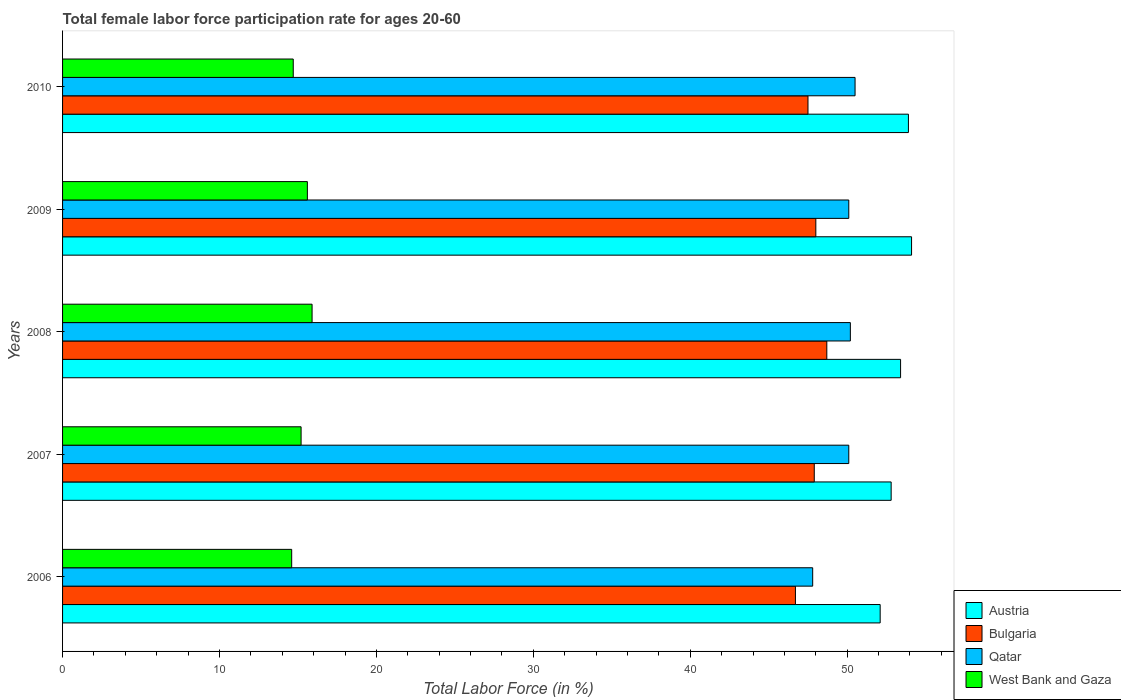How many different coloured bars are there?
Provide a succinct answer. 4. How many bars are there on the 4th tick from the top?
Ensure brevity in your answer.  4. What is the label of the 1st group of bars from the top?
Make the answer very short. 2010. What is the female labor force participation rate in West Bank and Gaza in 2007?
Provide a short and direct response. 15.2. Across all years, what is the maximum female labor force participation rate in West Bank and Gaza?
Your answer should be compact. 15.9. Across all years, what is the minimum female labor force participation rate in Bulgaria?
Provide a short and direct response. 46.7. In which year was the female labor force participation rate in Qatar minimum?
Provide a short and direct response. 2006. What is the total female labor force participation rate in Bulgaria in the graph?
Offer a very short reply. 238.8. What is the difference between the female labor force participation rate in Austria in 2008 and that in 2009?
Offer a terse response. -0.7. What is the difference between the female labor force participation rate in Bulgaria in 2010 and the female labor force participation rate in Qatar in 2007?
Your answer should be very brief. -2.6. What is the average female labor force participation rate in Bulgaria per year?
Ensure brevity in your answer.  47.76. In the year 2007, what is the difference between the female labor force participation rate in Austria and female labor force participation rate in West Bank and Gaza?
Offer a very short reply. 37.6. What is the ratio of the female labor force participation rate in Qatar in 2006 to that in 2008?
Keep it short and to the point. 0.95. Is the difference between the female labor force participation rate in Austria in 2008 and 2009 greater than the difference between the female labor force participation rate in West Bank and Gaza in 2008 and 2009?
Offer a very short reply. No. What is the difference between the highest and the second highest female labor force participation rate in Austria?
Offer a very short reply. 0.2. What is the difference between the highest and the lowest female labor force participation rate in Bulgaria?
Provide a short and direct response. 2. In how many years, is the female labor force participation rate in West Bank and Gaza greater than the average female labor force participation rate in West Bank and Gaza taken over all years?
Keep it short and to the point. 2. Is it the case that in every year, the sum of the female labor force participation rate in Qatar and female labor force participation rate in West Bank and Gaza is greater than the sum of female labor force participation rate in Austria and female labor force participation rate in Bulgaria?
Make the answer very short. Yes. What does the 1st bar from the top in 2006 represents?
Provide a short and direct response. West Bank and Gaza. What does the 3rd bar from the bottom in 2010 represents?
Keep it short and to the point. Qatar. How many bars are there?
Your answer should be very brief. 20. Are all the bars in the graph horizontal?
Offer a very short reply. Yes. What is the difference between two consecutive major ticks on the X-axis?
Your response must be concise. 10. Does the graph contain any zero values?
Give a very brief answer. No. Does the graph contain grids?
Keep it short and to the point. No. How are the legend labels stacked?
Keep it short and to the point. Vertical. What is the title of the graph?
Provide a succinct answer. Total female labor force participation rate for ages 20-60. What is the label or title of the X-axis?
Offer a very short reply. Total Labor Force (in %). What is the label or title of the Y-axis?
Offer a terse response. Years. What is the Total Labor Force (in %) of Austria in 2006?
Provide a succinct answer. 52.1. What is the Total Labor Force (in %) in Bulgaria in 2006?
Ensure brevity in your answer.  46.7. What is the Total Labor Force (in %) of Qatar in 2006?
Provide a succinct answer. 47.8. What is the Total Labor Force (in %) in West Bank and Gaza in 2006?
Your answer should be very brief. 14.6. What is the Total Labor Force (in %) in Austria in 2007?
Provide a succinct answer. 52.8. What is the Total Labor Force (in %) in Bulgaria in 2007?
Give a very brief answer. 47.9. What is the Total Labor Force (in %) of Qatar in 2007?
Keep it short and to the point. 50.1. What is the Total Labor Force (in %) of West Bank and Gaza in 2007?
Provide a short and direct response. 15.2. What is the Total Labor Force (in %) of Austria in 2008?
Your answer should be compact. 53.4. What is the Total Labor Force (in %) of Bulgaria in 2008?
Offer a terse response. 48.7. What is the Total Labor Force (in %) of Qatar in 2008?
Offer a terse response. 50.2. What is the Total Labor Force (in %) of West Bank and Gaza in 2008?
Provide a short and direct response. 15.9. What is the Total Labor Force (in %) of Austria in 2009?
Ensure brevity in your answer.  54.1. What is the Total Labor Force (in %) of Bulgaria in 2009?
Make the answer very short. 48. What is the Total Labor Force (in %) of Qatar in 2009?
Make the answer very short. 50.1. What is the Total Labor Force (in %) of West Bank and Gaza in 2009?
Provide a short and direct response. 15.6. What is the Total Labor Force (in %) of Austria in 2010?
Make the answer very short. 53.9. What is the Total Labor Force (in %) in Bulgaria in 2010?
Make the answer very short. 47.5. What is the Total Labor Force (in %) in Qatar in 2010?
Your response must be concise. 50.5. What is the Total Labor Force (in %) in West Bank and Gaza in 2010?
Provide a short and direct response. 14.7. Across all years, what is the maximum Total Labor Force (in %) in Austria?
Keep it short and to the point. 54.1. Across all years, what is the maximum Total Labor Force (in %) in Bulgaria?
Keep it short and to the point. 48.7. Across all years, what is the maximum Total Labor Force (in %) in Qatar?
Offer a terse response. 50.5. Across all years, what is the maximum Total Labor Force (in %) in West Bank and Gaza?
Offer a very short reply. 15.9. Across all years, what is the minimum Total Labor Force (in %) of Austria?
Make the answer very short. 52.1. Across all years, what is the minimum Total Labor Force (in %) in Bulgaria?
Provide a succinct answer. 46.7. Across all years, what is the minimum Total Labor Force (in %) in Qatar?
Your answer should be very brief. 47.8. Across all years, what is the minimum Total Labor Force (in %) of West Bank and Gaza?
Provide a succinct answer. 14.6. What is the total Total Labor Force (in %) in Austria in the graph?
Give a very brief answer. 266.3. What is the total Total Labor Force (in %) of Bulgaria in the graph?
Your response must be concise. 238.8. What is the total Total Labor Force (in %) in Qatar in the graph?
Ensure brevity in your answer.  248.7. What is the total Total Labor Force (in %) in West Bank and Gaza in the graph?
Your response must be concise. 76. What is the difference between the Total Labor Force (in %) of Qatar in 2006 and that in 2007?
Offer a terse response. -2.3. What is the difference between the Total Labor Force (in %) of Austria in 2006 and that in 2008?
Provide a succinct answer. -1.3. What is the difference between the Total Labor Force (in %) in Bulgaria in 2006 and that in 2008?
Give a very brief answer. -2. What is the difference between the Total Labor Force (in %) in West Bank and Gaza in 2006 and that in 2009?
Give a very brief answer. -1. What is the difference between the Total Labor Force (in %) of Austria in 2006 and that in 2010?
Offer a very short reply. -1.8. What is the difference between the Total Labor Force (in %) of Bulgaria in 2006 and that in 2010?
Your answer should be compact. -0.8. What is the difference between the Total Labor Force (in %) in Qatar in 2006 and that in 2010?
Make the answer very short. -2.7. What is the difference between the Total Labor Force (in %) in West Bank and Gaza in 2006 and that in 2010?
Your response must be concise. -0.1. What is the difference between the Total Labor Force (in %) of Austria in 2007 and that in 2008?
Offer a very short reply. -0.6. What is the difference between the Total Labor Force (in %) of Bulgaria in 2007 and that in 2008?
Offer a very short reply. -0.8. What is the difference between the Total Labor Force (in %) in Bulgaria in 2007 and that in 2010?
Offer a very short reply. 0.4. What is the difference between the Total Labor Force (in %) of Bulgaria in 2008 and that in 2009?
Provide a short and direct response. 0.7. What is the difference between the Total Labor Force (in %) in West Bank and Gaza in 2008 and that in 2009?
Your answer should be very brief. 0.3. What is the difference between the Total Labor Force (in %) of Austria in 2008 and that in 2010?
Your response must be concise. -0.5. What is the difference between the Total Labor Force (in %) in Qatar in 2008 and that in 2010?
Your answer should be very brief. -0.3. What is the difference between the Total Labor Force (in %) of West Bank and Gaza in 2008 and that in 2010?
Your answer should be compact. 1.2. What is the difference between the Total Labor Force (in %) of Bulgaria in 2009 and that in 2010?
Keep it short and to the point. 0.5. What is the difference between the Total Labor Force (in %) in Austria in 2006 and the Total Labor Force (in %) in Bulgaria in 2007?
Your response must be concise. 4.2. What is the difference between the Total Labor Force (in %) of Austria in 2006 and the Total Labor Force (in %) of Qatar in 2007?
Give a very brief answer. 2. What is the difference between the Total Labor Force (in %) of Austria in 2006 and the Total Labor Force (in %) of West Bank and Gaza in 2007?
Offer a very short reply. 36.9. What is the difference between the Total Labor Force (in %) in Bulgaria in 2006 and the Total Labor Force (in %) in Qatar in 2007?
Your answer should be compact. -3.4. What is the difference between the Total Labor Force (in %) of Bulgaria in 2006 and the Total Labor Force (in %) of West Bank and Gaza in 2007?
Offer a very short reply. 31.5. What is the difference between the Total Labor Force (in %) of Qatar in 2006 and the Total Labor Force (in %) of West Bank and Gaza in 2007?
Offer a terse response. 32.6. What is the difference between the Total Labor Force (in %) in Austria in 2006 and the Total Labor Force (in %) in Bulgaria in 2008?
Provide a succinct answer. 3.4. What is the difference between the Total Labor Force (in %) in Austria in 2006 and the Total Labor Force (in %) in West Bank and Gaza in 2008?
Ensure brevity in your answer.  36.2. What is the difference between the Total Labor Force (in %) in Bulgaria in 2006 and the Total Labor Force (in %) in Qatar in 2008?
Provide a succinct answer. -3.5. What is the difference between the Total Labor Force (in %) in Bulgaria in 2006 and the Total Labor Force (in %) in West Bank and Gaza in 2008?
Your response must be concise. 30.8. What is the difference between the Total Labor Force (in %) in Qatar in 2006 and the Total Labor Force (in %) in West Bank and Gaza in 2008?
Offer a very short reply. 31.9. What is the difference between the Total Labor Force (in %) of Austria in 2006 and the Total Labor Force (in %) of Qatar in 2009?
Ensure brevity in your answer.  2. What is the difference between the Total Labor Force (in %) of Austria in 2006 and the Total Labor Force (in %) of West Bank and Gaza in 2009?
Provide a succinct answer. 36.5. What is the difference between the Total Labor Force (in %) of Bulgaria in 2006 and the Total Labor Force (in %) of Qatar in 2009?
Your response must be concise. -3.4. What is the difference between the Total Labor Force (in %) in Bulgaria in 2006 and the Total Labor Force (in %) in West Bank and Gaza in 2009?
Offer a terse response. 31.1. What is the difference between the Total Labor Force (in %) of Qatar in 2006 and the Total Labor Force (in %) of West Bank and Gaza in 2009?
Make the answer very short. 32.2. What is the difference between the Total Labor Force (in %) of Austria in 2006 and the Total Labor Force (in %) of Bulgaria in 2010?
Your answer should be very brief. 4.6. What is the difference between the Total Labor Force (in %) in Austria in 2006 and the Total Labor Force (in %) in West Bank and Gaza in 2010?
Your answer should be compact. 37.4. What is the difference between the Total Labor Force (in %) of Qatar in 2006 and the Total Labor Force (in %) of West Bank and Gaza in 2010?
Your answer should be compact. 33.1. What is the difference between the Total Labor Force (in %) in Austria in 2007 and the Total Labor Force (in %) in West Bank and Gaza in 2008?
Provide a succinct answer. 36.9. What is the difference between the Total Labor Force (in %) in Bulgaria in 2007 and the Total Labor Force (in %) in West Bank and Gaza in 2008?
Make the answer very short. 32. What is the difference between the Total Labor Force (in %) of Qatar in 2007 and the Total Labor Force (in %) of West Bank and Gaza in 2008?
Keep it short and to the point. 34.2. What is the difference between the Total Labor Force (in %) in Austria in 2007 and the Total Labor Force (in %) in Qatar in 2009?
Keep it short and to the point. 2.7. What is the difference between the Total Labor Force (in %) of Austria in 2007 and the Total Labor Force (in %) of West Bank and Gaza in 2009?
Your response must be concise. 37.2. What is the difference between the Total Labor Force (in %) of Bulgaria in 2007 and the Total Labor Force (in %) of West Bank and Gaza in 2009?
Ensure brevity in your answer.  32.3. What is the difference between the Total Labor Force (in %) in Qatar in 2007 and the Total Labor Force (in %) in West Bank and Gaza in 2009?
Keep it short and to the point. 34.5. What is the difference between the Total Labor Force (in %) in Austria in 2007 and the Total Labor Force (in %) in Bulgaria in 2010?
Make the answer very short. 5.3. What is the difference between the Total Labor Force (in %) of Austria in 2007 and the Total Labor Force (in %) of Qatar in 2010?
Keep it short and to the point. 2.3. What is the difference between the Total Labor Force (in %) of Austria in 2007 and the Total Labor Force (in %) of West Bank and Gaza in 2010?
Provide a succinct answer. 38.1. What is the difference between the Total Labor Force (in %) in Bulgaria in 2007 and the Total Labor Force (in %) in West Bank and Gaza in 2010?
Your answer should be compact. 33.2. What is the difference between the Total Labor Force (in %) of Qatar in 2007 and the Total Labor Force (in %) of West Bank and Gaza in 2010?
Your response must be concise. 35.4. What is the difference between the Total Labor Force (in %) in Austria in 2008 and the Total Labor Force (in %) in Bulgaria in 2009?
Your answer should be compact. 5.4. What is the difference between the Total Labor Force (in %) in Austria in 2008 and the Total Labor Force (in %) in West Bank and Gaza in 2009?
Your response must be concise. 37.8. What is the difference between the Total Labor Force (in %) of Bulgaria in 2008 and the Total Labor Force (in %) of West Bank and Gaza in 2009?
Your answer should be very brief. 33.1. What is the difference between the Total Labor Force (in %) of Qatar in 2008 and the Total Labor Force (in %) of West Bank and Gaza in 2009?
Your answer should be compact. 34.6. What is the difference between the Total Labor Force (in %) of Austria in 2008 and the Total Labor Force (in %) of West Bank and Gaza in 2010?
Keep it short and to the point. 38.7. What is the difference between the Total Labor Force (in %) of Bulgaria in 2008 and the Total Labor Force (in %) of Qatar in 2010?
Your answer should be very brief. -1.8. What is the difference between the Total Labor Force (in %) of Qatar in 2008 and the Total Labor Force (in %) of West Bank and Gaza in 2010?
Your answer should be compact. 35.5. What is the difference between the Total Labor Force (in %) of Austria in 2009 and the Total Labor Force (in %) of West Bank and Gaza in 2010?
Your response must be concise. 39.4. What is the difference between the Total Labor Force (in %) of Bulgaria in 2009 and the Total Labor Force (in %) of Qatar in 2010?
Keep it short and to the point. -2.5. What is the difference between the Total Labor Force (in %) in Bulgaria in 2009 and the Total Labor Force (in %) in West Bank and Gaza in 2010?
Ensure brevity in your answer.  33.3. What is the difference between the Total Labor Force (in %) of Qatar in 2009 and the Total Labor Force (in %) of West Bank and Gaza in 2010?
Offer a very short reply. 35.4. What is the average Total Labor Force (in %) in Austria per year?
Offer a terse response. 53.26. What is the average Total Labor Force (in %) in Bulgaria per year?
Your answer should be compact. 47.76. What is the average Total Labor Force (in %) in Qatar per year?
Keep it short and to the point. 49.74. What is the average Total Labor Force (in %) of West Bank and Gaza per year?
Make the answer very short. 15.2. In the year 2006, what is the difference between the Total Labor Force (in %) in Austria and Total Labor Force (in %) in Bulgaria?
Keep it short and to the point. 5.4. In the year 2006, what is the difference between the Total Labor Force (in %) in Austria and Total Labor Force (in %) in Qatar?
Provide a succinct answer. 4.3. In the year 2006, what is the difference between the Total Labor Force (in %) of Austria and Total Labor Force (in %) of West Bank and Gaza?
Make the answer very short. 37.5. In the year 2006, what is the difference between the Total Labor Force (in %) of Bulgaria and Total Labor Force (in %) of West Bank and Gaza?
Offer a terse response. 32.1. In the year 2006, what is the difference between the Total Labor Force (in %) of Qatar and Total Labor Force (in %) of West Bank and Gaza?
Your answer should be very brief. 33.2. In the year 2007, what is the difference between the Total Labor Force (in %) in Austria and Total Labor Force (in %) in Bulgaria?
Offer a terse response. 4.9. In the year 2007, what is the difference between the Total Labor Force (in %) in Austria and Total Labor Force (in %) in West Bank and Gaza?
Your response must be concise. 37.6. In the year 2007, what is the difference between the Total Labor Force (in %) of Bulgaria and Total Labor Force (in %) of West Bank and Gaza?
Offer a terse response. 32.7. In the year 2007, what is the difference between the Total Labor Force (in %) in Qatar and Total Labor Force (in %) in West Bank and Gaza?
Ensure brevity in your answer.  34.9. In the year 2008, what is the difference between the Total Labor Force (in %) in Austria and Total Labor Force (in %) in Qatar?
Keep it short and to the point. 3.2. In the year 2008, what is the difference between the Total Labor Force (in %) in Austria and Total Labor Force (in %) in West Bank and Gaza?
Offer a very short reply. 37.5. In the year 2008, what is the difference between the Total Labor Force (in %) in Bulgaria and Total Labor Force (in %) in Qatar?
Your answer should be compact. -1.5. In the year 2008, what is the difference between the Total Labor Force (in %) of Bulgaria and Total Labor Force (in %) of West Bank and Gaza?
Offer a terse response. 32.8. In the year 2008, what is the difference between the Total Labor Force (in %) in Qatar and Total Labor Force (in %) in West Bank and Gaza?
Offer a terse response. 34.3. In the year 2009, what is the difference between the Total Labor Force (in %) in Austria and Total Labor Force (in %) in West Bank and Gaza?
Make the answer very short. 38.5. In the year 2009, what is the difference between the Total Labor Force (in %) in Bulgaria and Total Labor Force (in %) in Qatar?
Give a very brief answer. -2.1. In the year 2009, what is the difference between the Total Labor Force (in %) of Bulgaria and Total Labor Force (in %) of West Bank and Gaza?
Ensure brevity in your answer.  32.4. In the year 2009, what is the difference between the Total Labor Force (in %) in Qatar and Total Labor Force (in %) in West Bank and Gaza?
Your response must be concise. 34.5. In the year 2010, what is the difference between the Total Labor Force (in %) in Austria and Total Labor Force (in %) in West Bank and Gaza?
Ensure brevity in your answer.  39.2. In the year 2010, what is the difference between the Total Labor Force (in %) of Bulgaria and Total Labor Force (in %) of West Bank and Gaza?
Offer a very short reply. 32.8. In the year 2010, what is the difference between the Total Labor Force (in %) of Qatar and Total Labor Force (in %) of West Bank and Gaza?
Provide a succinct answer. 35.8. What is the ratio of the Total Labor Force (in %) in Austria in 2006 to that in 2007?
Provide a succinct answer. 0.99. What is the ratio of the Total Labor Force (in %) in Bulgaria in 2006 to that in 2007?
Provide a succinct answer. 0.97. What is the ratio of the Total Labor Force (in %) of Qatar in 2006 to that in 2007?
Your response must be concise. 0.95. What is the ratio of the Total Labor Force (in %) of West Bank and Gaza in 2006 to that in 2007?
Give a very brief answer. 0.96. What is the ratio of the Total Labor Force (in %) of Austria in 2006 to that in 2008?
Offer a very short reply. 0.98. What is the ratio of the Total Labor Force (in %) in Bulgaria in 2006 to that in 2008?
Your answer should be very brief. 0.96. What is the ratio of the Total Labor Force (in %) in Qatar in 2006 to that in 2008?
Offer a terse response. 0.95. What is the ratio of the Total Labor Force (in %) of West Bank and Gaza in 2006 to that in 2008?
Provide a short and direct response. 0.92. What is the ratio of the Total Labor Force (in %) in Bulgaria in 2006 to that in 2009?
Ensure brevity in your answer.  0.97. What is the ratio of the Total Labor Force (in %) of Qatar in 2006 to that in 2009?
Offer a terse response. 0.95. What is the ratio of the Total Labor Force (in %) in West Bank and Gaza in 2006 to that in 2009?
Make the answer very short. 0.94. What is the ratio of the Total Labor Force (in %) in Austria in 2006 to that in 2010?
Make the answer very short. 0.97. What is the ratio of the Total Labor Force (in %) in Bulgaria in 2006 to that in 2010?
Provide a short and direct response. 0.98. What is the ratio of the Total Labor Force (in %) of Qatar in 2006 to that in 2010?
Provide a succinct answer. 0.95. What is the ratio of the Total Labor Force (in %) of Austria in 2007 to that in 2008?
Ensure brevity in your answer.  0.99. What is the ratio of the Total Labor Force (in %) of Bulgaria in 2007 to that in 2008?
Provide a short and direct response. 0.98. What is the ratio of the Total Labor Force (in %) in Qatar in 2007 to that in 2008?
Provide a succinct answer. 1. What is the ratio of the Total Labor Force (in %) of West Bank and Gaza in 2007 to that in 2008?
Offer a very short reply. 0.96. What is the ratio of the Total Labor Force (in %) in Austria in 2007 to that in 2009?
Ensure brevity in your answer.  0.98. What is the ratio of the Total Labor Force (in %) of Bulgaria in 2007 to that in 2009?
Offer a terse response. 1. What is the ratio of the Total Labor Force (in %) in West Bank and Gaza in 2007 to that in 2009?
Your response must be concise. 0.97. What is the ratio of the Total Labor Force (in %) of Austria in 2007 to that in 2010?
Your answer should be very brief. 0.98. What is the ratio of the Total Labor Force (in %) of Bulgaria in 2007 to that in 2010?
Give a very brief answer. 1.01. What is the ratio of the Total Labor Force (in %) in Qatar in 2007 to that in 2010?
Offer a terse response. 0.99. What is the ratio of the Total Labor Force (in %) of West Bank and Gaza in 2007 to that in 2010?
Offer a very short reply. 1.03. What is the ratio of the Total Labor Force (in %) of Austria in 2008 to that in 2009?
Give a very brief answer. 0.99. What is the ratio of the Total Labor Force (in %) of Bulgaria in 2008 to that in 2009?
Provide a short and direct response. 1.01. What is the ratio of the Total Labor Force (in %) of Qatar in 2008 to that in 2009?
Give a very brief answer. 1. What is the ratio of the Total Labor Force (in %) of West Bank and Gaza in 2008 to that in 2009?
Offer a terse response. 1.02. What is the ratio of the Total Labor Force (in %) of Bulgaria in 2008 to that in 2010?
Make the answer very short. 1.03. What is the ratio of the Total Labor Force (in %) in Qatar in 2008 to that in 2010?
Offer a very short reply. 0.99. What is the ratio of the Total Labor Force (in %) of West Bank and Gaza in 2008 to that in 2010?
Your answer should be very brief. 1.08. What is the ratio of the Total Labor Force (in %) of Bulgaria in 2009 to that in 2010?
Offer a terse response. 1.01. What is the ratio of the Total Labor Force (in %) in West Bank and Gaza in 2009 to that in 2010?
Your answer should be very brief. 1.06. What is the difference between the highest and the second highest Total Labor Force (in %) of Bulgaria?
Provide a succinct answer. 0.7. What is the difference between the highest and the lowest Total Labor Force (in %) of Austria?
Keep it short and to the point. 2. What is the difference between the highest and the lowest Total Labor Force (in %) of Qatar?
Offer a terse response. 2.7. 